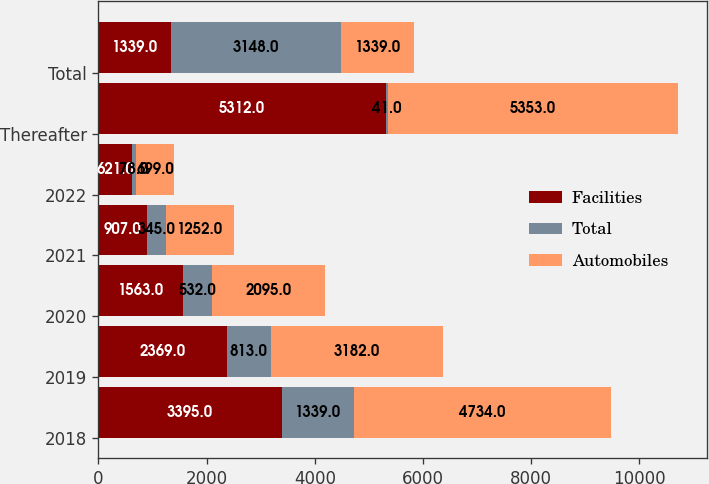Convert chart to OTSL. <chart><loc_0><loc_0><loc_500><loc_500><stacked_bar_chart><ecel><fcel>2018<fcel>2019<fcel>2020<fcel>2021<fcel>2022<fcel>Thereafter<fcel>Total<nl><fcel>Facilities<fcel>3395<fcel>2369<fcel>1563<fcel>907<fcel>621<fcel>5312<fcel>1339<nl><fcel>Total<fcel>1339<fcel>813<fcel>532<fcel>345<fcel>78<fcel>41<fcel>3148<nl><fcel>Automobiles<fcel>4734<fcel>3182<fcel>2095<fcel>1252<fcel>699<fcel>5353<fcel>1339<nl></chart> 